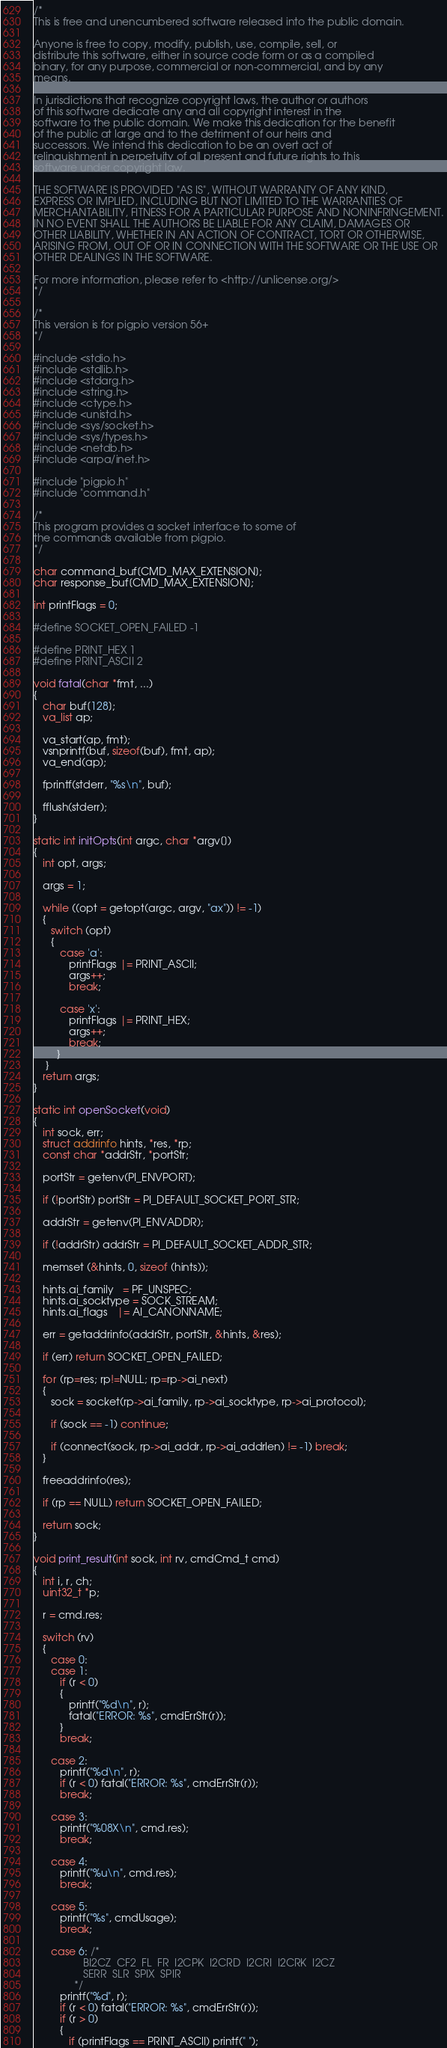<code> <loc_0><loc_0><loc_500><loc_500><_C_>/*
This is free and unencumbered software released into the public domain.

Anyone is free to copy, modify, publish, use, compile, sell, or
distribute this software, either in source code form or as a compiled
binary, for any purpose, commercial or non-commercial, and by any
means.

In jurisdictions that recognize copyright laws, the author or authors
of this software dedicate any and all copyright interest in the
software to the public domain. We make this dedication for the benefit
of the public at large and to the detriment of our heirs and
successors. We intend this dedication to be an overt act of
relinquishment in perpetuity of all present and future rights to this
software under copyright law.

THE SOFTWARE IS PROVIDED "AS IS", WITHOUT WARRANTY OF ANY KIND,
EXPRESS OR IMPLIED, INCLUDING BUT NOT LIMITED TO THE WARRANTIES OF
MERCHANTABILITY, FITNESS FOR A PARTICULAR PURPOSE AND NONINFRINGEMENT.
IN NO EVENT SHALL THE AUTHORS BE LIABLE FOR ANY CLAIM, DAMAGES OR
OTHER LIABILITY, WHETHER IN AN ACTION OF CONTRACT, TORT OR OTHERWISE,
ARISING FROM, OUT OF OR IN CONNECTION WITH THE SOFTWARE OR THE USE OR
OTHER DEALINGS IN THE SOFTWARE.

For more information, please refer to <http://unlicense.org/>
*/

/*
This version is for pigpio version 56+
*/

#include <stdio.h>
#include <stdlib.h>
#include <stdarg.h>
#include <string.h>
#include <ctype.h>
#include <unistd.h>
#include <sys/socket.h>
#include <sys/types.h>
#include <netdb.h>
#include <arpa/inet.h>

#include "pigpio.h"
#include "command.h"

/*
This program provides a socket interface to some of
the commands available from pigpio.
*/

char command_buf[CMD_MAX_EXTENSION];
char response_buf[CMD_MAX_EXTENSION];

int printFlags = 0;

#define SOCKET_OPEN_FAILED -1

#define PRINT_HEX 1
#define PRINT_ASCII 2

void fatal(char *fmt, ...)
{
   char buf[128];
   va_list ap;

   va_start(ap, fmt);
   vsnprintf(buf, sizeof(buf), fmt, ap);
   va_end(ap);

   fprintf(stderr, "%s\n", buf);

   fflush(stderr);
}

static int initOpts(int argc, char *argv[])
{
   int opt, args;

   args = 1;

   while ((opt = getopt(argc, argv, "ax")) != -1)
   {
      switch (opt)
      {
         case 'a':
            printFlags |= PRINT_ASCII;
            args++;
            break;

         case 'x':
            printFlags |= PRINT_HEX;
            args++;
            break;
        }
    }
   return args;
}

static int openSocket(void)
{
   int sock, err;
   struct addrinfo hints, *res, *rp;
   const char *addrStr, *portStr;

   portStr = getenv(PI_ENVPORT);

   if (!portStr) portStr = PI_DEFAULT_SOCKET_PORT_STR;

   addrStr = getenv(PI_ENVADDR);

   if (!addrStr) addrStr = PI_DEFAULT_SOCKET_ADDR_STR;

   memset (&hints, 0, sizeof (hints));

   hints.ai_family   = PF_UNSPEC;
   hints.ai_socktype = SOCK_STREAM;
   hints.ai_flags   |= AI_CANONNAME;

   err = getaddrinfo(addrStr, portStr, &hints, &res);

   if (err) return SOCKET_OPEN_FAILED;

   for (rp=res; rp!=NULL; rp=rp->ai_next)
   {
      sock = socket(rp->ai_family, rp->ai_socktype, rp->ai_protocol);

      if (sock == -1) continue;

      if (connect(sock, rp->ai_addr, rp->ai_addrlen) != -1) break;
   }

   freeaddrinfo(res);

   if (rp == NULL) return SOCKET_OPEN_FAILED;

   return sock;
}

void print_result(int sock, int rv, cmdCmd_t cmd)
{
   int i, r, ch;
   uint32_t *p;

   r = cmd.res;

   switch (rv)
   {
      case 0:
      case 1:
         if (r < 0)
         {
            printf("%d\n", r);
            fatal("ERROR: %s", cmdErrStr(r));
         }
         break;

      case 2:
         printf("%d\n", r);
         if (r < 0) fatal("ERROR: %s", cmdErrStr(r));
         break;

      case 3:
         printf("%08X\n", cmd.res);
         break;

      case 4:
         printf("%u\n", cmd.res);
         break;

      case 5:
         printf("%s", cmdUsage);
         break;

      case 6: /*
                 BI2CZ  CF2  FL  FR  I2CPK  I2CRD  I2CRI  I2CRK  I2CZ
                 SERR  SLR  SPIX  SPIR
              */
         printf("%d", r);
         if (r < 0) fatal("ERROR: %s", cmdErrStr(r));
         if (r > 0)
         {
            if (printFlags == PRINT_ASCII) printf(" ");
</code> 